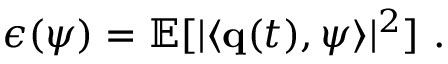Convert formula to latex. <formula><loc_0><loc_0><loc_500><loc_500>\epsilon ( \psi ) = \mathbb { E } [ | \langle { q } ( t ) , \psi \rangle | ^ { 2 } ] .</formula> 